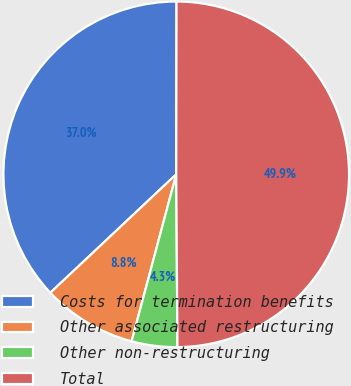Convert chart. <chart><loc_0><loc_0><loc_500><loc_500><pie_chart><fcel>Costs for termination benefits<fcel>Other associated restructuring<fcel>Other non-restructuring<fcel>Total<nl><fcel>37.04%<fcel>8.83%<fcel>4.27%<fcel>49.86%<nl></chart> 